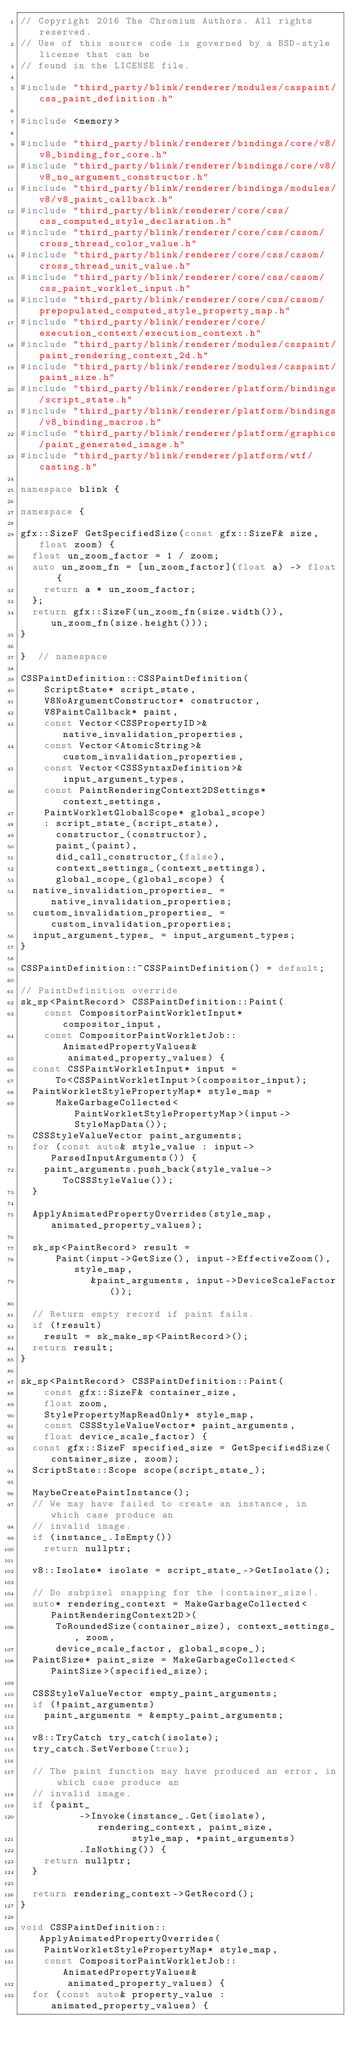Convert code to text. <code><loc_0><loc_0><loc_500><loc_500><_C++_>// Copyright 2016 The Chromium Authors. All rights reserved.
// Use of this source code is governed by a BSD-style license that can be
// found in the LICENSE file.

#include "third_party/blink/renderer/modules/csspaint/css_paint_definition.h"

#include <memory>

#include "third_party/blink/renderer/bindings/core/v8/v8_binding_for_core.h"
#include "third_party/blink/renderer/bindings/core/v8/v8_no_argument_constructor.h"
#include "third_party/blink/renderer/bindings/modules/v8/v8_paint_callback.h"
#include "third_party/blink/renderer/core/css/css_computed_style_declaration.h"
#include "third_party/blink/renderer/core/css/cssom/cross_thread_color_value.h"
#include "third_party/blink/renderer/core/css/cssom/cross_thread_unit_value.h"
#include "third_party/blink/renderer/core/css/cssom/css_paint_worklet_input.h"
#include "third_party/blink/renderer/core/css/cssom/prepopulated_computed_style_property_map.h"
#include "third_party/blink/renderer/core/execution_context/execution_context.h"
#include "third_party/blink/renderer/modules/csspaint/paint_rendering_context_2d.h"
#include "third_party/blink/renderer/modules/csspaint/paint_size.h"
#include "third_party/blink/renderer/platform/bindings/script_state.h"
#include "third_party/blink/renderer/platform/bindings/v8_binding_macros.h"
#include "third_party/blink/renderer/platform/graphics/paint_generated_image.h"
#include "third_party/blink/renderer/platform/wtf/casting.h"

namespace blink {

namespace {

gfx::SizeF GetSpecifiedSize(const gfx::SizeF& size, float zoom) {
  float un_zoom_factor = 1 / zoom;
  auto un_zoom_fn = [un_zoom_factor](float a) -> float {
    return a * un_zoom_factor;
  };
  return gfx::SizeF(un_zoom_fn(size.width()), un_zoom_fn(size.height()));
}

}  // namespace

CSSPaintDefinition::CSSPaintDefinition(
    ScriptState* script_state,
    V8NoArgumentConstructor* constructor,
    V8PaintCallback* paint,
    const Vector<CSSPropertyID>& native_invalidation_properties,
    const Vector<AtomicString>& custom_invalidation_properties,
    const Vector<CSSSyntaxDefinition>& input_argument_types,
    const PaintRenderingContext2DSettings* context_settings,
    PaintWorkletGlobalScope* global_scope)
    : script_state_(script_state),
      constructor_(constructor),
      paint_(paint),
      did_call_constructor_(false),
      context_settings_(context_settings),
      global_scope_(global_scope) {
  native_invalidation_properties_ = native_invalidation_properties;
  custom_invalidation_properties_ = custom_invalidation_properties;
  input_argument_types_ = input_argument_types;
}

CSSPaintDefinition::~CSSPaintDefinition() = default;

// PaintDefinition override
sk_sp<PaintRecord> CSSPaintDefinition::Paint(
    const CompositorPaintWorkletInput* compositor_input,
    const CompositorPaintWorkletJob::AnimatedPropertyValues&
        animated_property_values) {
  const CSSPaintWorkletInput* input =
      To<CSSPaintWorkletInput>(compositor_input);
  PaintWorkletStylePropertyMap* style_map =
      MakeGarbageCollected<PaintWorkletStylePropertyMap>(input->StyleMapData());
  CSSStyleValueVector paint_arguments;
  for (const auto& style_value : input->ParsedInputArguments()) {
    paint_arguments.push_back(style_value->ToCSSStyleValue());
  }

  ApplyAnimatedPropertyOverrides(style_map, animated_property_values);

  sk_sp<PaintRecord> result =
      Paint(input->GetSize(), input->EffectiveZoom(), style_map,
            &paint_arguments, input->DeviceScaleFactor());

  // Return empty record if paint fails.
  if (!result)
    result = sk_make_sp<PaintRecord>();
  return result;
}

sk_sp<PaintRecord> CSSPaintDefinition::Paint(
    const gfx::SizeF& container_size,
    float zoom,
    StylePropertyMapReadOnly* style_map,
    const CSSStyleValueVector* paint_arguments,
    float device_scale_factor) {
  const gfx::SizeF specified_size = GetSpecifiedSize(container_size, zoom);
  ScriptState::Scope scope(script_state_);

  MaybeCreatePaintInstance();
  // We may have failed to create an instance, in which case produce an
  // invalid image.
  if (instance_.IsEmpty())
    return nullptr;

  v8::Isolate* isolate = script_state_->GetIsolate();

  // Do subpixel snapping for the |container_size|.
  auto* rendering_context = MakeGarbageCollected<PaintRenderingContext2D>(
      ToRoundedSize(container_size), context_settings_, zoom,
      device_scale_factor, global_scope_);
  PaintSize* paint_size = MakeGarbageCollected<PaintSize>(specified_size);

  CSSStyleValueVector empty_paint_arguments;
  if (!paint_arguments)
    paint_arguments = &empty_paint_arguments;

  v8::TryCatch try_catch(isolate);
  try_catch.SetVerbose(true);

  // The paint function may have produced an error, in which case produce an
  // invalid image.
  if (paint_
          ->Invoke(instance_.Get(isolate), rendering_context, paint_size,
                   style_map, *paint_arguments)
          .IsNothing()) {
    return nullptr;
  }

  return rendering_context->GetRecord();
}

void CSSPaintDefinition::ApplyAnimatedPropertyOverrides(
    PaintWorkletStylePropertyMap* style_map,
    const CompositorPaintWorkletJob::AnimatedPropertyValues&
        animated_property_values) {
  for (const auto& property_value : animated_property_values) {</code> 